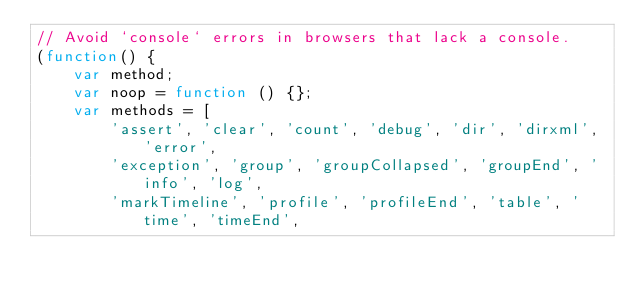<code> <loc_0><loc_0><loc_500><loc_500><_JavaScript_>// Avoid `console` errors in browsers that lack a console.
(function() {
    var method;
    var noop = function () {};
    var methods = [
        'assert', 'clear', 'count', 'debug', 'dir', 'dirxml', 'error',
        'exception', 'group', 'groupCollapsed', 'groupEnd', 'info', 'log',
        'markTimeline', 'profile', 'profileEnd', 'table', 'time', 'timeEnd',</code> 